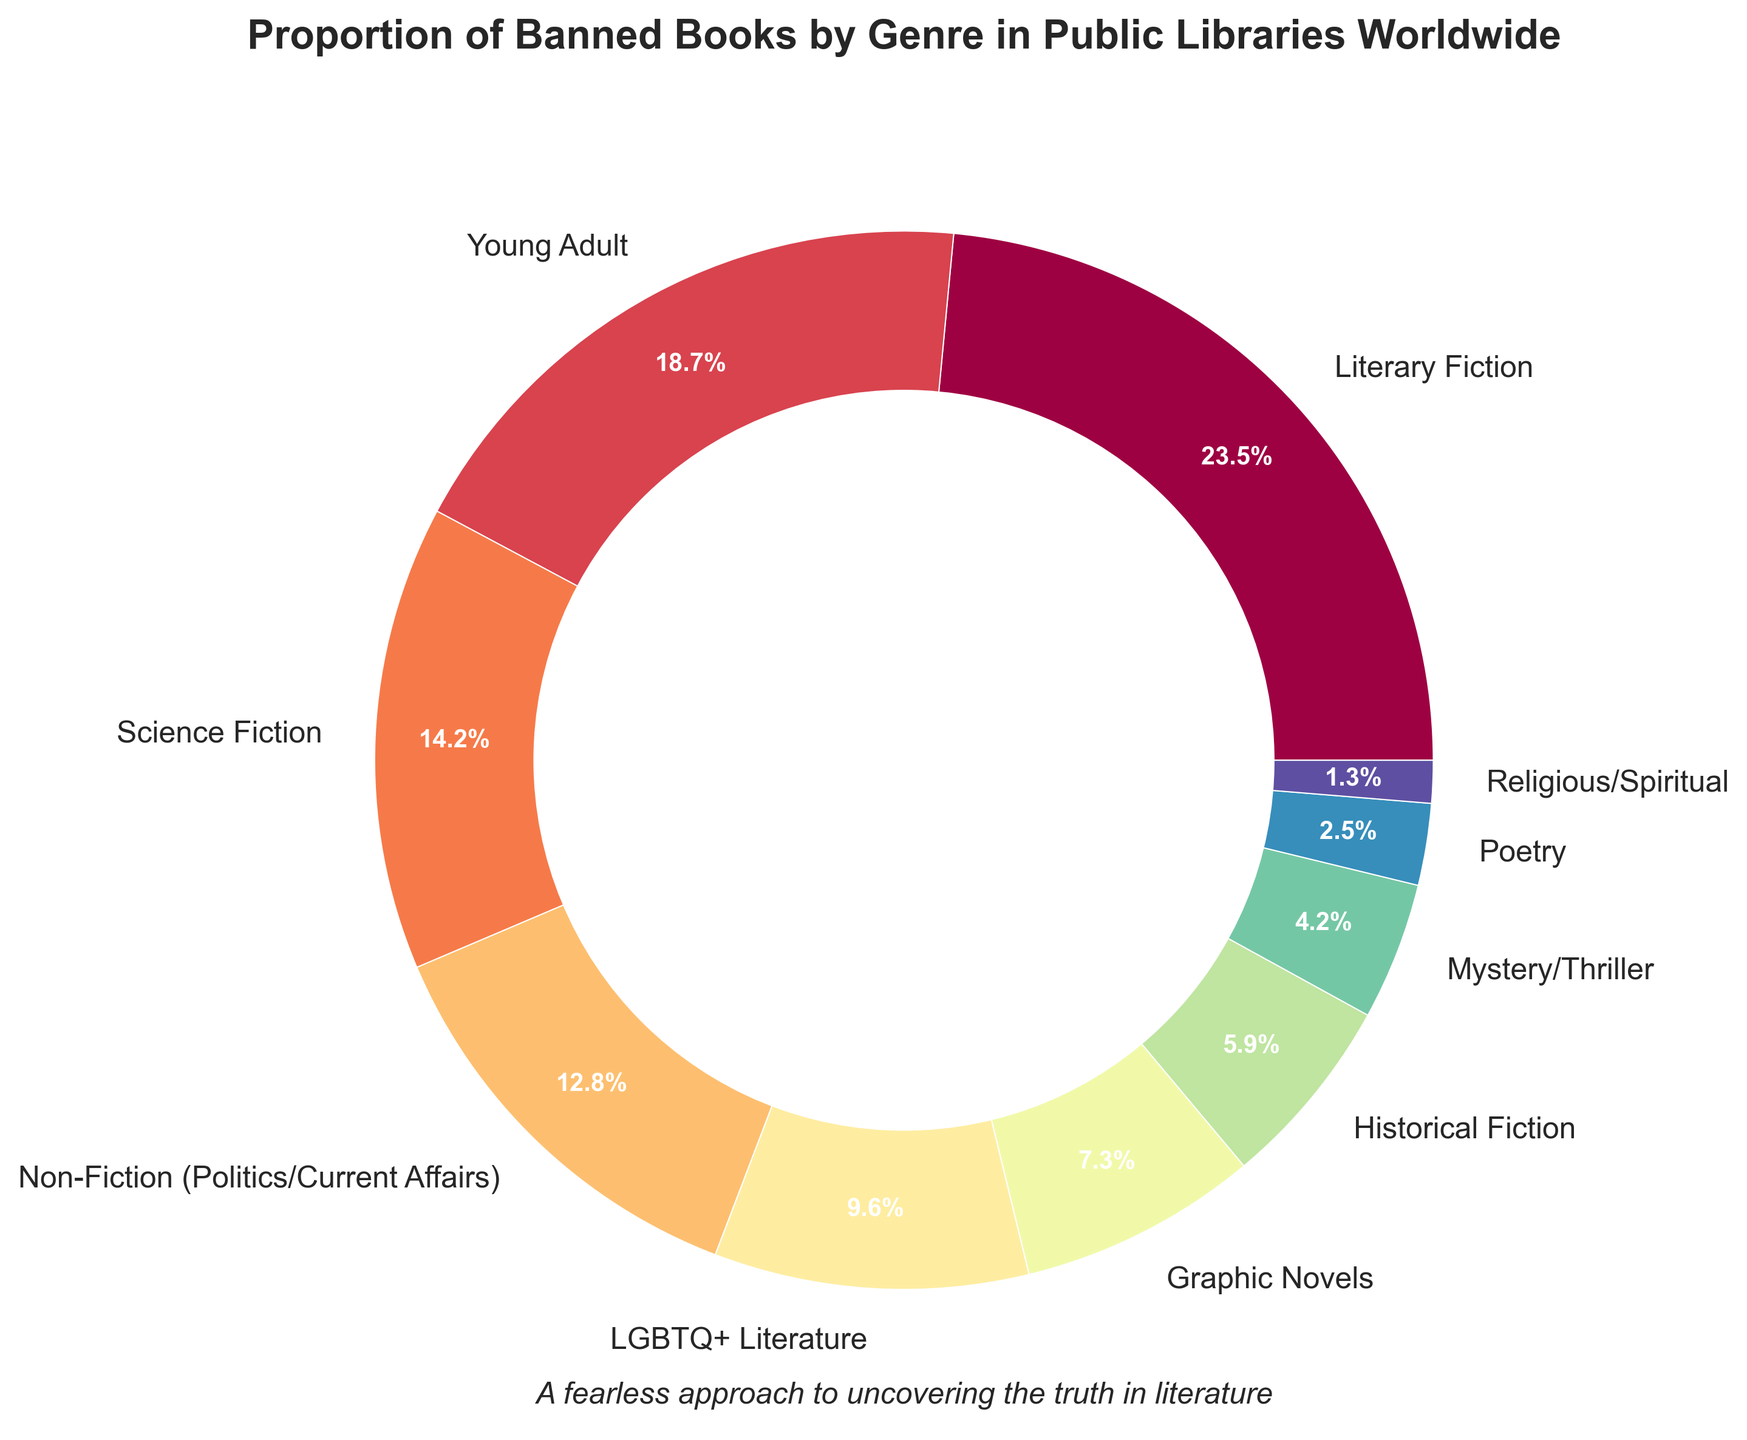What's the genre with the highest proportion of banned books? The figure shows different genres with their respective percentages. The genre with the highest percentage of banned books is Literary Fiction with 23.5%.
Answer: Literary Fiction Which genre represents less than 5% of banned books? By looking at the figure, the genres with less than 5% are Mystery/Thriller (4.2%), Poetry (2.5%), and Religious/Spiritual (1.3%).
Answer: Mystery/Thriller, Poetry, Religious/Spiritual What's the difference in the proportion of banned books between Literary Fiction and Young Adult genres? Literary Fiction has 23.5% and Young Adult has 18.7%. The difference is calculated as 23.5% - 18.7% = 4.8%.
Answer: 4.8% What proportion of banned books do Science Fiction and Non-Fiction (Politics/Current Affairs) together represent? Science Fiction has 14.2% and Non-Fiction (Politics/Current Affairs) has 12.8%. The total is calculated as 14.2% + 12.8% = 27%.
Answer: 27% Which genre has a greater proportion of banned books: Historical Fiction or Graphic Novels? Historical Fiction has 5.9%, while Graphic Novels have 7.3%, indicating Graphic Novels have a greater proportion.
Answer: Graphic Novels What is the total proportion of banned books for genres with a percentage higher than 10%? The genres are Literary Fiction (23.5%), Young Adult (18.7%), Science Fiction (14.2%), and Non-Fiction (Politics/Current Affairs) (12.8%). Adding these, 23.5% + 18.7% + 14.2% + 12.8% = 69.2%.
Answer: 69.2% Is the proportion of LGBTQ+ Literature banned books greater than that of Historical Fiction and Mystery/Thriller combined? LGBTQ+ Literature has 9.6%. Historical Fiction and Mystery/Thriller combined is 5.9% + 4.2% = 10.1%. Since 9.6% is less than 10.1%, it is not greater.
Answer: No Which genre is almost equal to Non-Fiction (Politics/Current Affairs) in the proportion of banned books? The genre closest to Non-Fiction (Politics/Current Affairs) with 12.8% is Science Fiction with 14.2%, as the difference is only 1.4%.
Answer: Science Fiction What's the average proportion of banned books for the genres with the lowest three percentages? The lowest three are Mystery/Thriller (4.2%), Poetry (2.5%), and Religious/Spiritual (1.3%). The average is calculated as (4.2% + 2.5% + 1.3%) / 3 ≈ 2.67%.
Answer: 2.67% What proportion of banned books do genres excluding Literary Fiction and Young Adult represent? Excluding Literary Fiction (23.5%) and Young Adult (18.7%), the sum of the remaining genres' percentages is 100% - (23.5% + 18.7%) = 57.8%.
Answer: 57.8% 